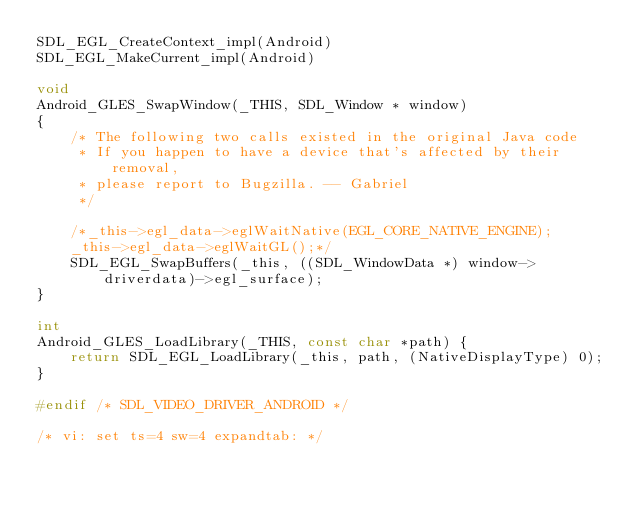<code> <loc_0><loc_0><loc_500><loc_500><_C_>SDL_EGL_CreateContext_impl(Android)
SDL_EGL_MakeCurrent_impl(Android)

void
Android_GLES_SwapWindow(_THIS, SDL_Window * window)
{
    /* The following two calls existed in the original Java code
     * If you happen to have a device that's affected by their removal,
     * please report to Bugzilla. -- Gabriel
     */
    
    /*_this->egl_data->eglWaitNative(EGL_CORE_NATIVE_ENGINE);
    _this->egl_data->eglWaitGL();*/
    SDL_EGL_SwapBuffers(_this, ((SDL_WindowData *) window->driverdata)->egl_surface);
}

int
Android_GLES_LoadLibrary(_THIS, const char *path) {
    return SDL_EGL_LoadLibrary(_this, path, (NativeDisplayType) 0);
}

#endif /* SDL_VIDEO_DRIVER_ANDROID */

/* vi: set ts=4 sw=4 expandtab: */
</code> 